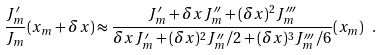Convert formula to latex. <formula><loc_0><loc_0><loc_500><loc_500>\frac { J _ { m } ^ { \prime } } { J _ { m } } ( x _ { m } + \delta x ) \approx \frac { J _ { m } ^ { \prime } + \delta x J _ { m } ^ { \prime \prime } + ( \delta x ) ^ { 2 } J _ { m } ^ { \prime \prime \prime } } { \delta x J _ { m } ^ { \prime } + ( \delta x ) ^ { 2 } J _ { m } ^ { \prime \prime } / 2 + ( \delta x ) ^ { 3 } J _ { m } ^ { \prime \prime \prime } / 6 } ( x _ { m } ) \ .</formula> 